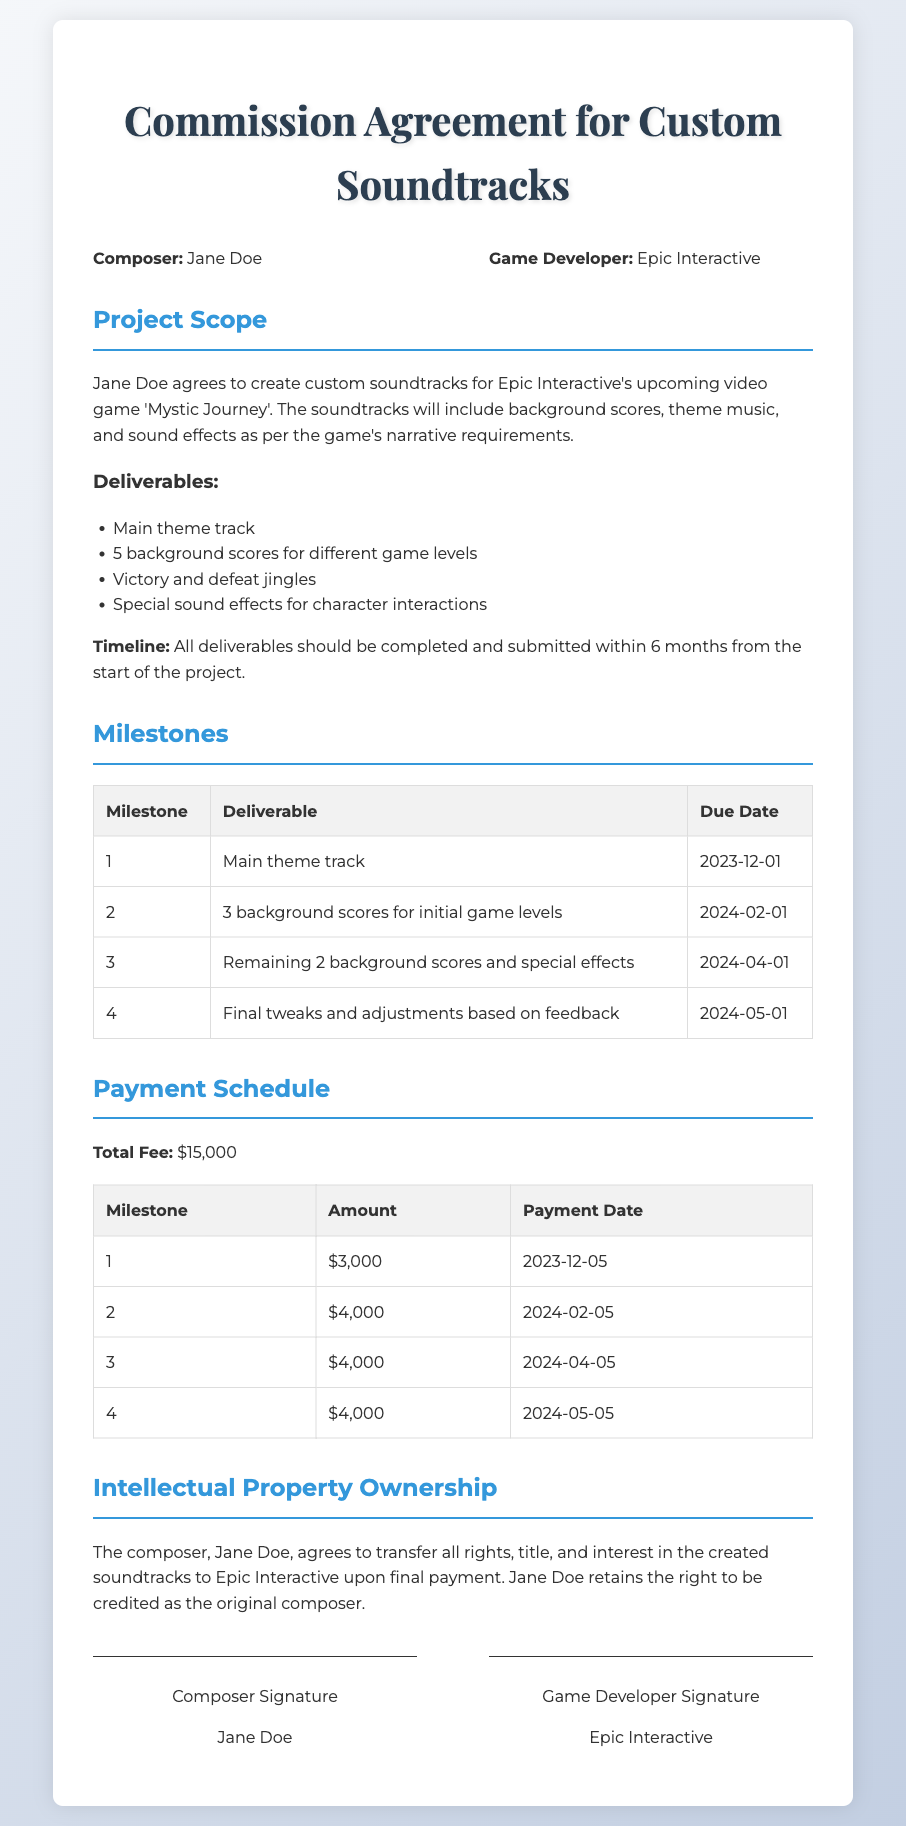What is the composer's name? The composer's name is mentioned at the beginning of the document as Jane Doe.
Answer: Jane Doe What is the total fee for the project? The total fee is specified in the Payment Schedule section as $15,000.
Answer: $15,000 How many background scores are required for different game levels? The document lists that there are 5 background scores needed for different game levels as part of the deliverables.
Answer: 5 When is the due date for the main theme track? The due date for the main theme track is provided in the Milestones table as December 1, 2023.
Answer: 2023-12-01 What rights does the composer retain? The document states that the composer retains the right to be credited as the original composer after transferring rights to Epic Interactive.
Answer: To be credited as the original composer What is the second payment amount? The second payment amount is specified in the Payment Schedule table as $4,000.
Answer: $4,000 What is the final milestone due date? The final milestone due date for tweaks and adjustments is June 1, 2024, as per the Milestones section.
Answer: 2024-05-01 How many deliverables are listed under the Project Scope? The document lists four specific deliverables under the Project Scope section.
Answer: 4 What is the name of the video game? The video game for which the soundtracks are created is named 'Mystic Journey' as stated in the Project Scope.
Answer: Mystic Journey 